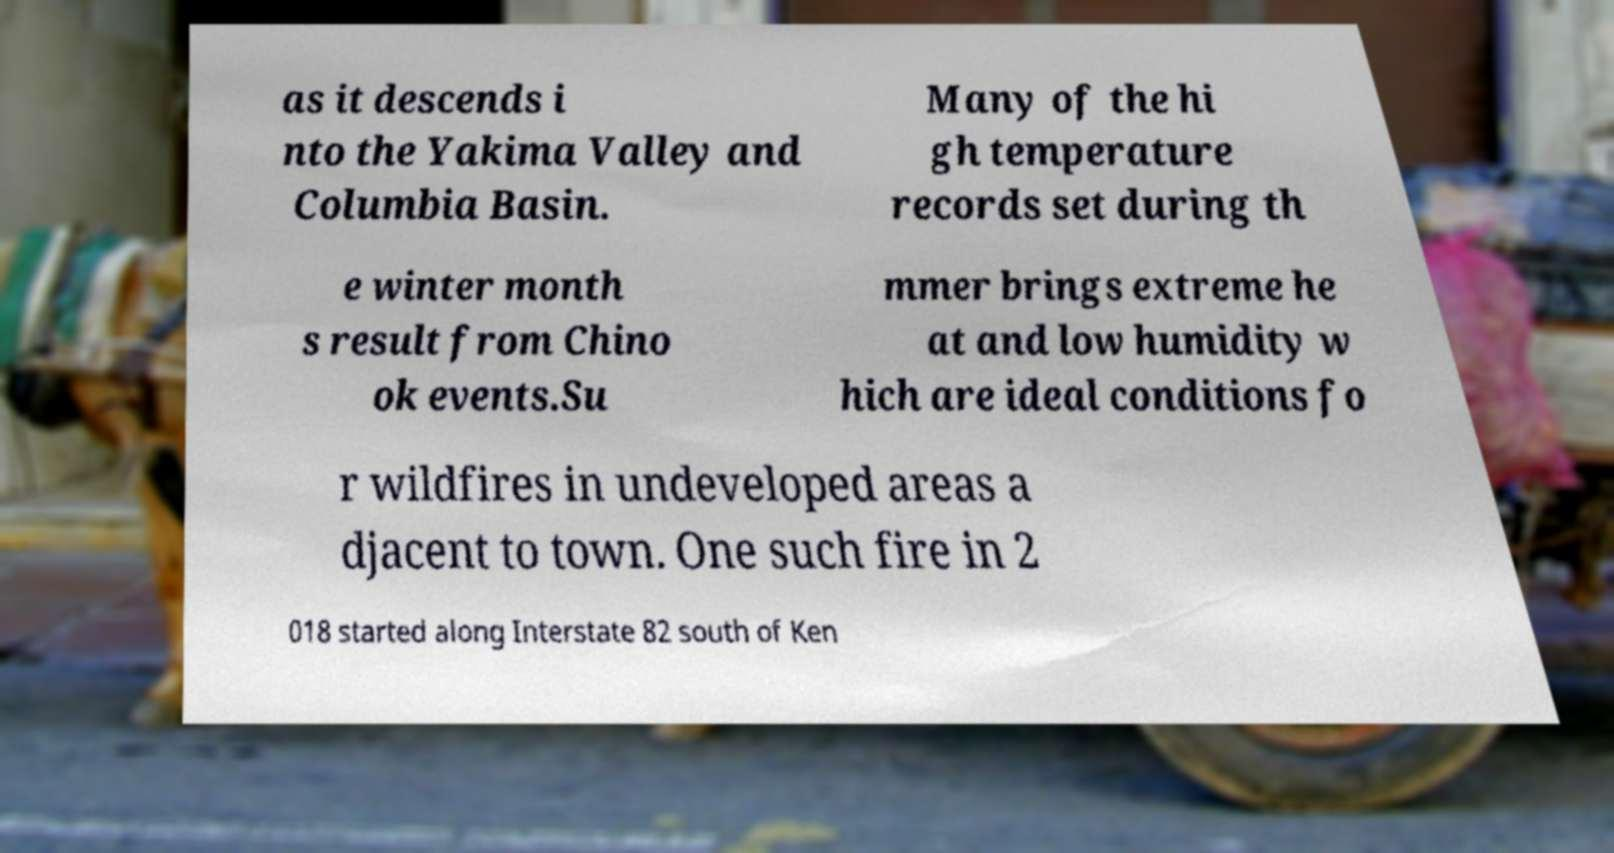Please identify and transcribe the text found in this image. as it descends i nto the Yakima Valley and Columbia Basin. Many of the hi gh temperature records set during th e winter month s result from Chino ok events.Su mmer brings extreme he at and low humidity w hich are ideal conditions fo r wildfires in undeveloped areas a djacent to town. One such fire in 2 018 started along Interstate 82 south of Ken 